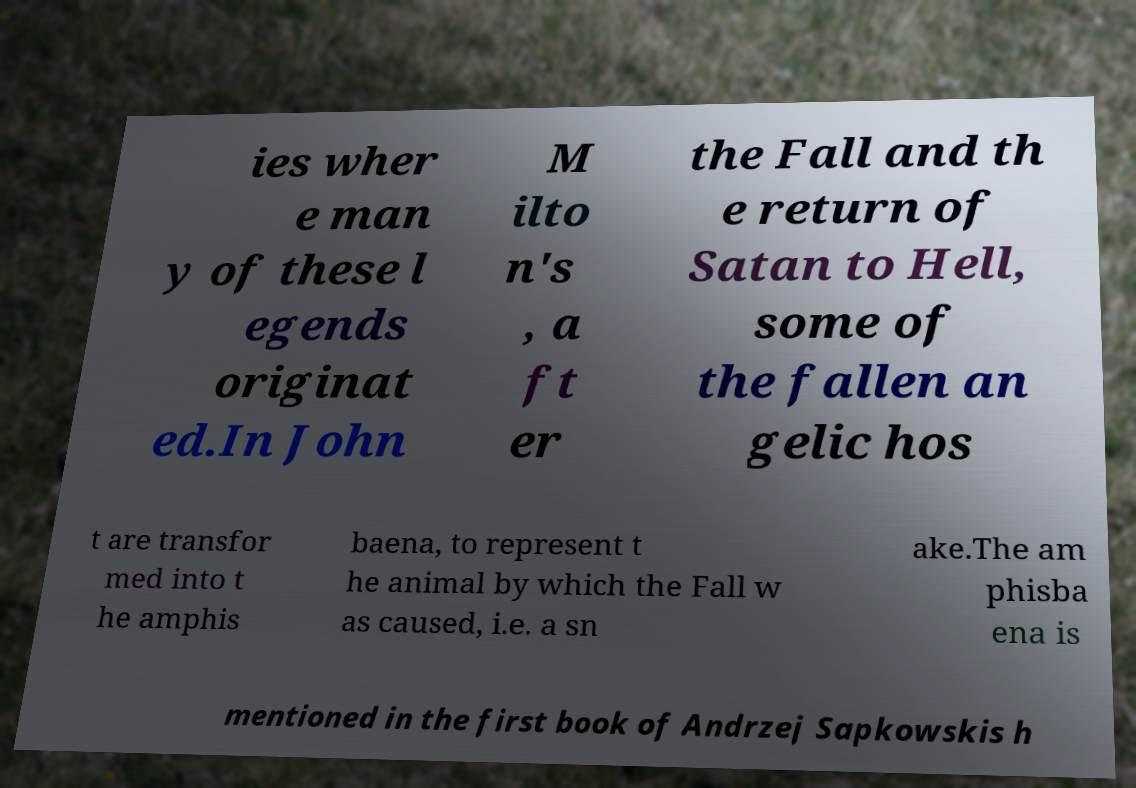I need the written content from this picture converted into text. Can you do that? ies wher e man y of these l egends originat ed.In John M ilto n's , a ft er the Fall and th e return of Satan to Hell, some of the fallen an gelic hos t are transfor med into t he amphis baena, to represent t he animal by which the Fall w as caused, i.e. a sn ake.The am phisba ena is mentioned in the first book of Andrzej Sapkowskis h 